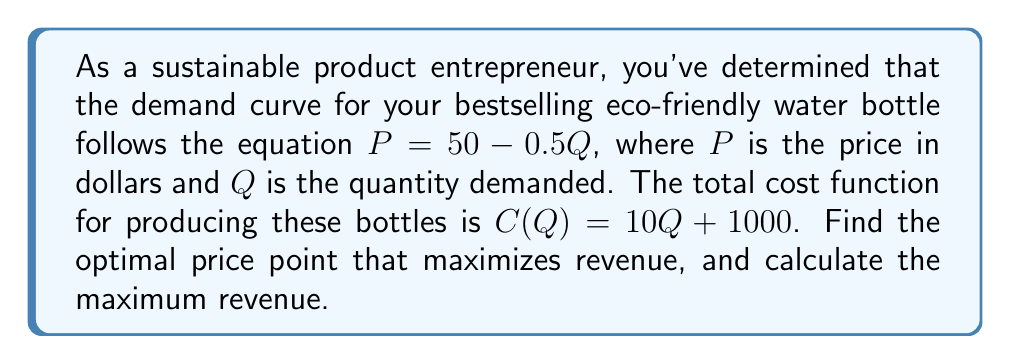Teach me how to tackle this problem. 1) First, we need to find the revenue function. Revenue is price times quantity:
   $R = PQ = (50 - 0.5Q)Q = 50Q - 0.5Q^2$

2) To find the maximum revenue, we need to find the derivative of the revenue function and set it equal to zero:
   $\frac{dR}{dQ} = 50 - Q$

3) Set this equal to zero and solve for Q:
   $50 - Q = 0$
   $Q = 50$

4) This critical point will give us the quantity that maximizes revenue. To find the optimal price, we plug this quantity back into our original demand equation:
   $P = 50 - 0.5(50) = 25$

5) Therefore, the optimal price point is $25.

6) To calculate the maximum revenue, we can use either the revenue function or simply multiply optimal price by optimal quantity:
   $R_{max} = 25 * 50 = 1250$
Answer: Optimal price: $25; Maximum revenue: $1250 